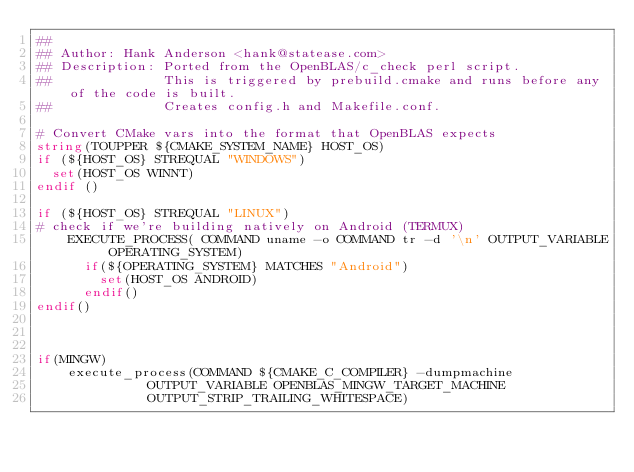Convert code to text. <code><loc_0><loc_0><loc_500><loc_500><_CMake_>##
## Author: Hank Anderson <hank@statease.com>
## Description: Ported from the OpenBLAS/c_check perl script.
##              This is triggered by prebuild.cmake and runs before any of the code is built.
##              Creates config.h and Makefile.conf.

# Convert CMake vars into the format that OpenBLAS expects
string(TOUPPER ${CMAKE_SYSTEM_NAME} HOST_OS)
if (${HOST_OS} STREQUAL "WINDOWS")
  set(HOST_OS WINNT)
endif ()

if (${HOST_OS} STREQUAL "LINUX")
# check if we're building natively on Android (TERMUX)
    EXECUTE_PROCESS( COMMAND uname -o COMMAND tr -d '\n' OUTPUT_VARIABLE OPERATING_SYSTEM)
      if(${OPERATING_SYSTEM} MATCHES "Android")
        set(HOST_OS ANDROID)
      endif()
endif()



if(MINGW)
    execute_process(COMMAND ${CMAKE_C_COMPILER} -dumpmachine
              OUTPUT_VARIABLE OPENBLAS_MINGW_TARGET_MACHINE
              OUTPUT_STRIP_TRAILING_WHITESPACE)</code> 